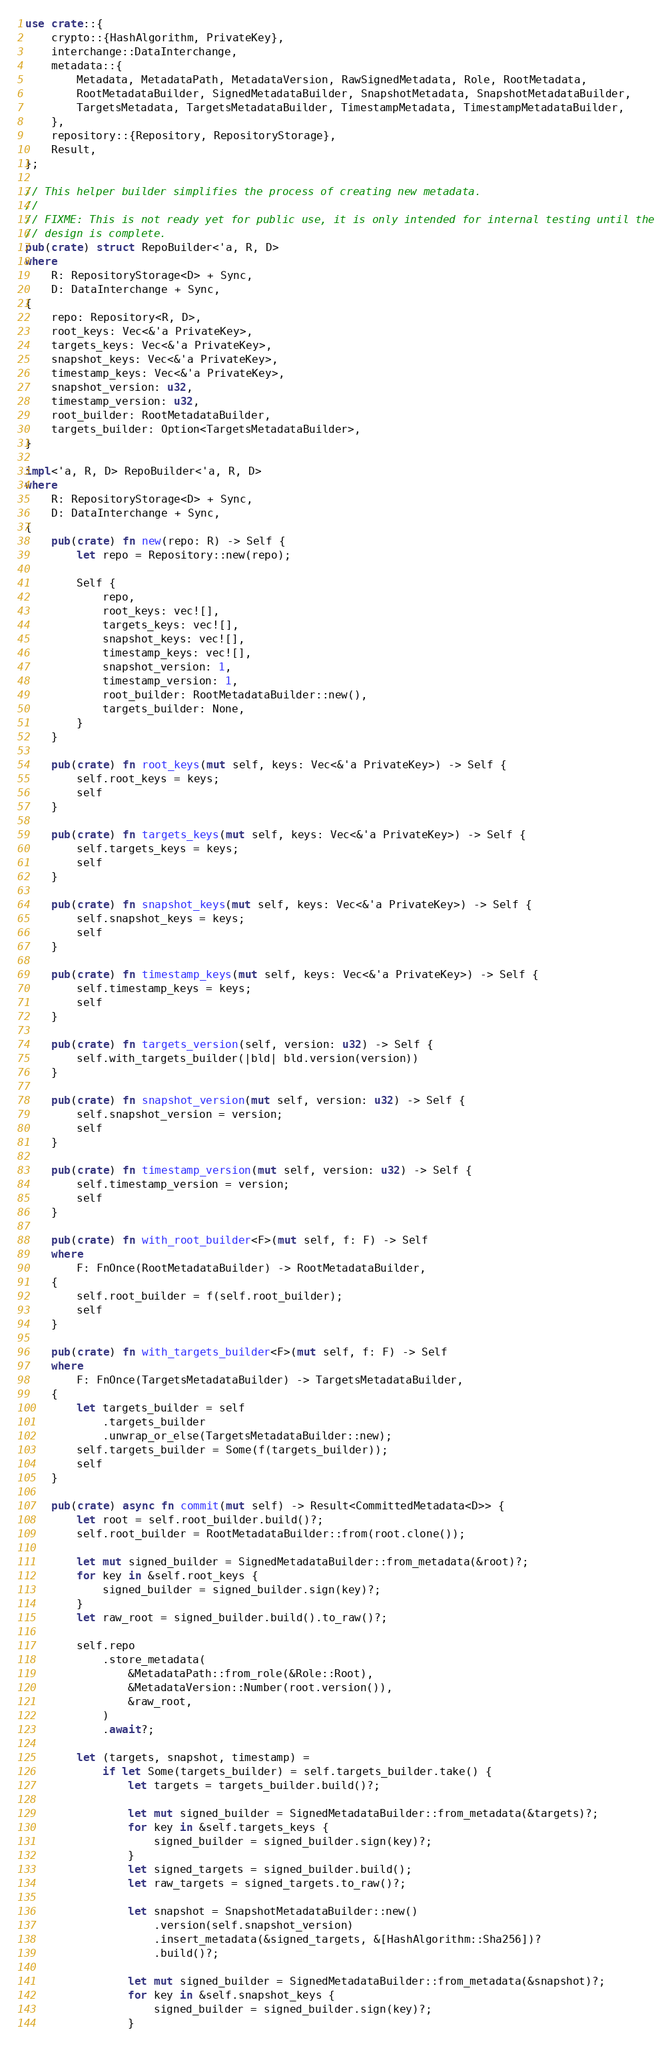Convert code to text. <code><loc_0><loc_0><loc_500><loc_500><_Rust_>use crate::{
    crypto::{HashAlgorithm, PrivateKey},
    interchange::DataInterchange,
    metadata::{
        Metadata, MetadataPath, MetadataVersion, RawSignedMetadata, Role, RootMetadata,
        RootMetadataBuilder, SignedMetadataBuilder, SnapshotMetadata, SnapshotMetadataBuilder,
        TargetsMetadata, TargetsMetadataBuilder, TimestampMetadata, TimestampMetadataBuilder,
    },
    repository::{Repository, RepositoryStorage},
    Result,
};

// This helper builder simplifies the process of creating new metadata.
//
// FIXME: This is not ready yet for public use, it is only intended for internal testing until the
// design is complete.
pub(crate) struct RepoBuilder<'a, R, D>
where
    R: RepositoryStorage<D> + Sync,
    D: DataInterchange + Sync,
{
    repo: Repository<R, D>,
    root_keys: Vec<&'a PrivateKey>,
    targets_keys: Vec<&'a PrivateKey>,
    snapshot_keys: Vec<&'a PrivateKey>,
    timestamp_keys: Vec<&'a PrivateKey>,
    snapshot_version: u32,
    timestamp_version: u32,
    root_builder: RootMetadataBuilder,
    targets_builder: Option<TargetsMetadataBuilder>,
}

impl<'a, R, D> RepoBuilder<'a, R, D>
where
    R: RepositoryStorage<D> + Sync,
    D: DataInterchange + Sync,
{
    pub(crate) fn new(repo: R) -> Self {
        let repo = Repository::new(repo);

        Self {
            repo,
            root_keys: vec![],
            targets_keys: vec![],
            snapshot_keys: vec![],
            timestamp_keys: vec![],
            snapshot_version: 1,
            timestamp_version: 1,
            root_builder: RootMetadataBuilder::new(),
            targets_builder: None,
        }
    }

    pub(crate) fn root_keys(mut self, keys: Vec<&'a PrivateKey>) -> Self {
        self.root_keys = keys;
        self
    }

    pub(crate) fn targets_keys(mut self, keys: Vec<&'a PrivateKey>) -> Self {
        self.targets_keys = keys;
        self
    }

    pub(crate) fn snapshot_keys(mut self, keys: Vec<&'a PrivateKey>) -> Self {
        self.snapshot_keys = keys;
        self
    }

    pub(crate) fn timestamp_keys(mut self, keys: Vec<&'a PrivateKey>) -> Self {
        self.timestamp_keys = keys;
        self
    }

    pub(crate) fn targets_version(self, version: u32) -> Self {
        self.with_targets_builder(|bld| bld.version(version))
    }

    pub(crate) fn snapshot_version(mut self, version: u32) -> Self {
        self.snapshot_version = version;
        self
    }

    pub(crate) fn timestamp_version(mut self, version: u32) -> Self {
        self.timestamp_version = version;
        self
    }

    pub(crate) fn with_root_builder<F>(mut self, f: F) -> Self
    where
        F: FnOnce(RootMetadataBuilder) -> RootMetadataBuilder,
    {
        self.root_builder = f(self.root_builder);
        self
    }

    pub(crate) fn with_targets_builder<F>(mut self, f: F) -> Self
    where
        F: FnOnce(TargetsMetadataBuilder) -> TargetsMetadataBuilder,
    {
        let targets_builder = self
            .targets_builder
            .unwrap_or_else(TargetsMetadataBuilder::new);
        self.targets_builder = Some(f(targets_builder));
        self
    }

    pub(crate) async fn commit(mut self) -> Result<CommittedMetadata<D>> {
        let root = self.root_builder.build()?;
        self.root_builder = RootMetadataBuilder::from(root.clone());

        let mut signed_builder = SignedMetadataBuilder::from_metadata(&root)?;
        for key in &self.root_keys {
            signed_builder = signed_builder.sign(key)?;
        }
        let raw_root = signed_builder.build().to_raw()?;

        self.repo
            .store_metadata(
                &MetadataPath::from_role(&Role::Root),
                &MetadataVersion::Number(root.version()),
                &raw_root,
            )
            .await?;

        let (targets, snapshot, timestamp) =
            if let Some(targets_builder) = self.targets_builder.take() {
                let targets = targets_builder.build()?;

                let mut signed_builder = SignedMetadataBuilder::from_metadata(&targets)?;
                for key in &self.targets_keys {
                    signed_builder = signed_builder.sign(key)?;
                }
                let signed_targets = signed_builder.build();
                let raw_targets = signed_targets.to_raw()?;

                let snapshot = SnapshotMetadataBuilder::new()
                    .version(self.snapshot_version)
                    .insert_metadata(&signed_targets, &[HashAlgorithm::Sha256])?
                    .build()?;

                let mut signed_builder = SignedMetadataBuilder::from_metadata(&snapshot)?;
                for key in &self.snapshot_keys {
                    signed_builder = signed_builder.sign(key)?;
                }</code> 